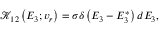<formula> <loc_0><loc_0><loc_500><loc_500>\mathcal { K } _ { 1 2 } \left ( E _ { 3 } ; v _ { r } \right ) = \sigma \delta \left ( E _ { 3 } - E _ { 3 } ^ { * } \right ) d E _ { 3 } ,</formula> 